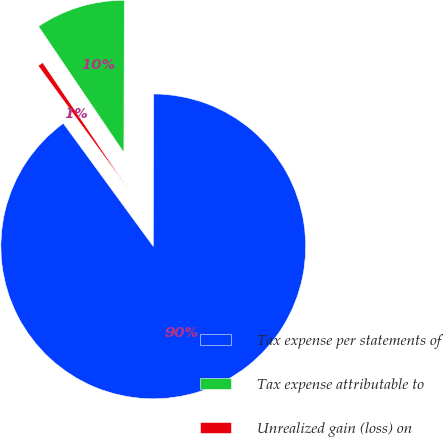<chart> <loc_0><loc_0><loc_500><loc_500><pie_chart><fcel>Tax expense per statements of<fcel>Tax expense attributable to<fcel>Unrealized gain (loss) on<nl><fcel>89.91%<fcel>9.51%<fcel>0.58%<nl></chart> 